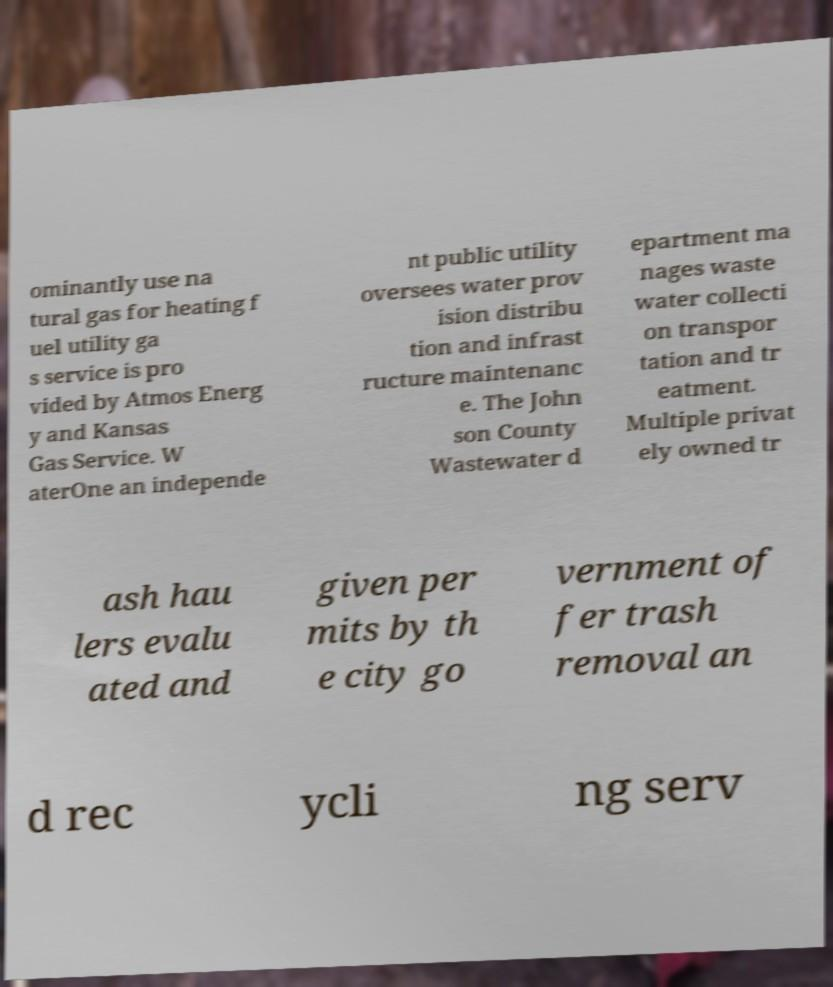Could you assist in decoding the text presented in this image and type it out clearly? ominantly use na tural gas for heating f uel utility ga s service is pro vided by Atmos Energ y and Kansas Gas Service. W aterOne an independe nt public utility oversees water prov ision distribu tion and infrast ructure maintenanc e. The John son County Wastewater d epartment ma nages waste water collecti on transpor tation and tr eatment. Multiple privat ely owned tr ash hau lers evalu ated and given per mits by th e city go vernment of fer trash removal an d rec ycli ng serv 